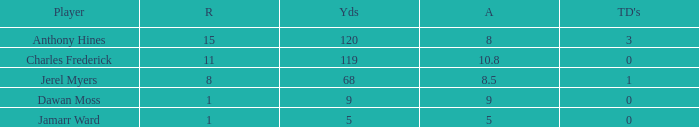What is the highest number of TDs when the Avg is larger than 8.5 and the Rec is less than 1? None. 